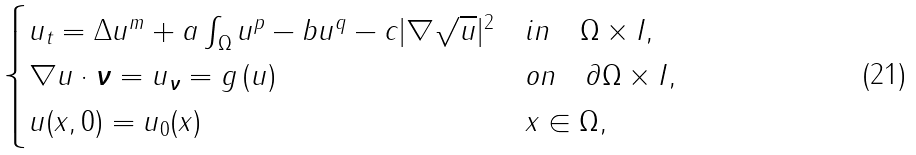<formula> <loc_0><loc_0><loc_500><loc_500>\begin{cases} u _ { t } = \Delta u ^ { m } + a \int _ { \Omega } u ^ { p } - b u ^ { q } - c | \nabla \sqrt { u } | ^ { 2 } & i n \quad \Omega \times I , \\ \nabla u \cdot \boldsymbol \nu = u _ { \boldsymbol \nu } = g \left ( u \right ) & o n \quad \partial \Omega \times I , \\ u ( { x } , 0 ) = u _ { 0 } ( { x } ) & { x } \in \Omega , \end{cases}</formula> 